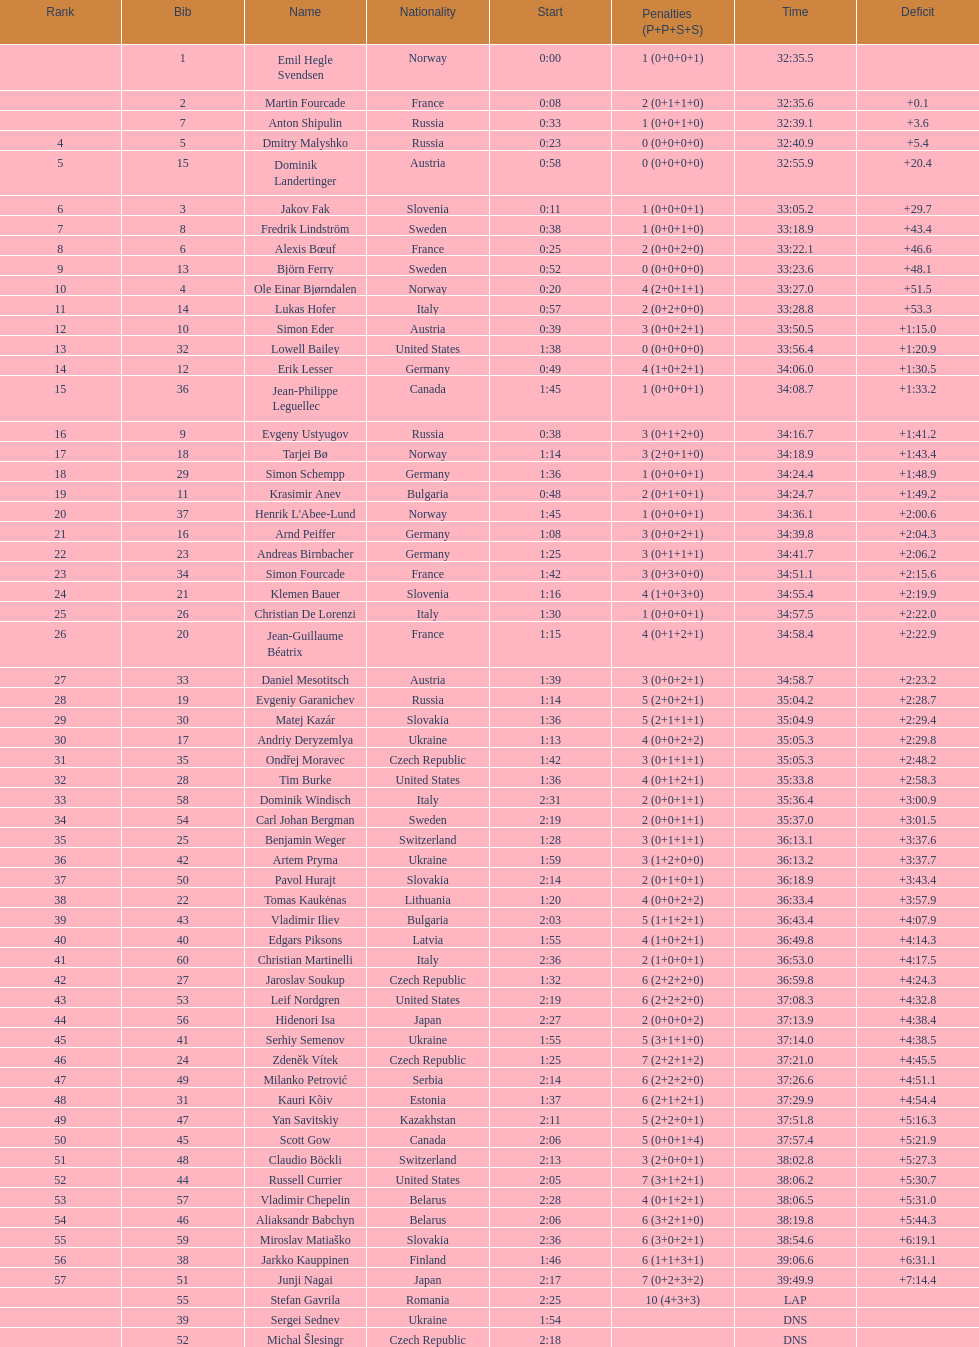Excluding burke, provide the name of a competitor from the united states. Leif Nordgren. 